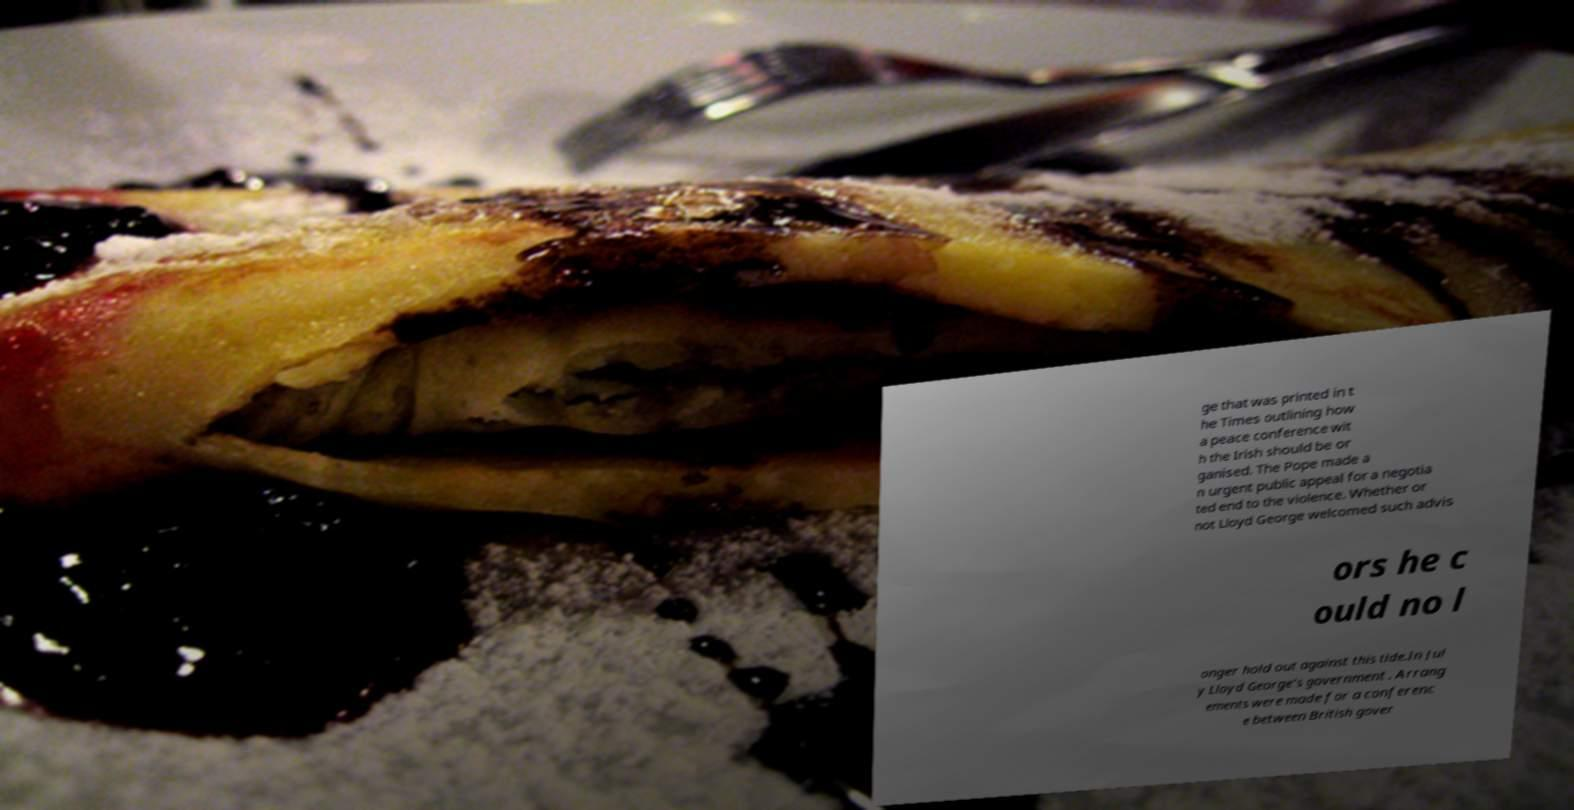Please read and relay the text visible in this image. What does it say? ge that was printed in t he Times outlining how a peace conference wit h the Irish should be or ganised. The Pope made a n urgent public appeal for a negotia ted end to the violence. Whether or not Lloyd George welcomed such advis ors he c ould no l onger hold out against this tide.In Jul y Lloyd George's government . Arrang ements were made for a conferenc e between British gover 